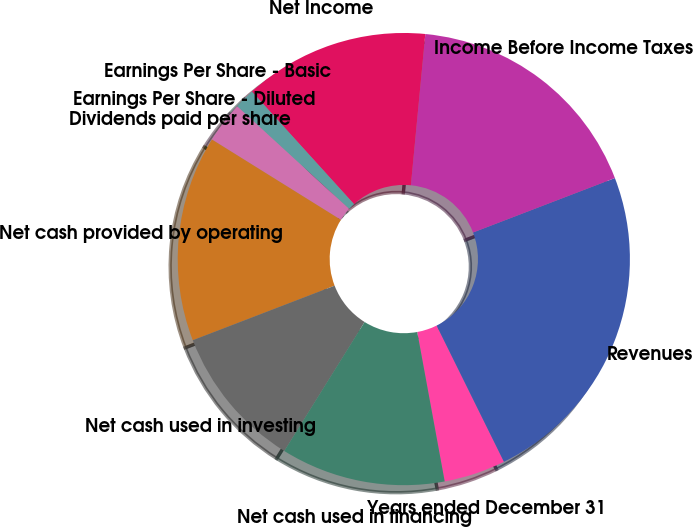Convert chart to OTSL. <chart><loc_0><loc_0><loc_500><loc_500><pie_chart><fcel>Years ended December 31<fcel>Revenues<fcel>Income Before Income Taxes<fcel>Net Income<fcel>Earnings Per Share - Basic<fcel>Earnings Per Share - Diluted<fcel>Dividends paid per share<fcel>Net cash provided by operating<fcel>Net cash used in investing<fcel>Net cash used in financing<nl><fcel>4.41%<fcel>23.53%<fcel>17.65%<fcel>13.24%<fcel>1.47%<fcel>2.94%<fcel>0.0%<fcel>14.71%<fcel>10.29%<fcel>11.76%<nl></chart> 